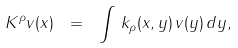Convert formula to latex. <formula><loc_0><loc_0><loc_500><loc_500>K ^ { \rho } v ( x ) \ = \ \int \, k _ { \rho } ( x , y ) \, v ( y ) \, d y ,</formula> 